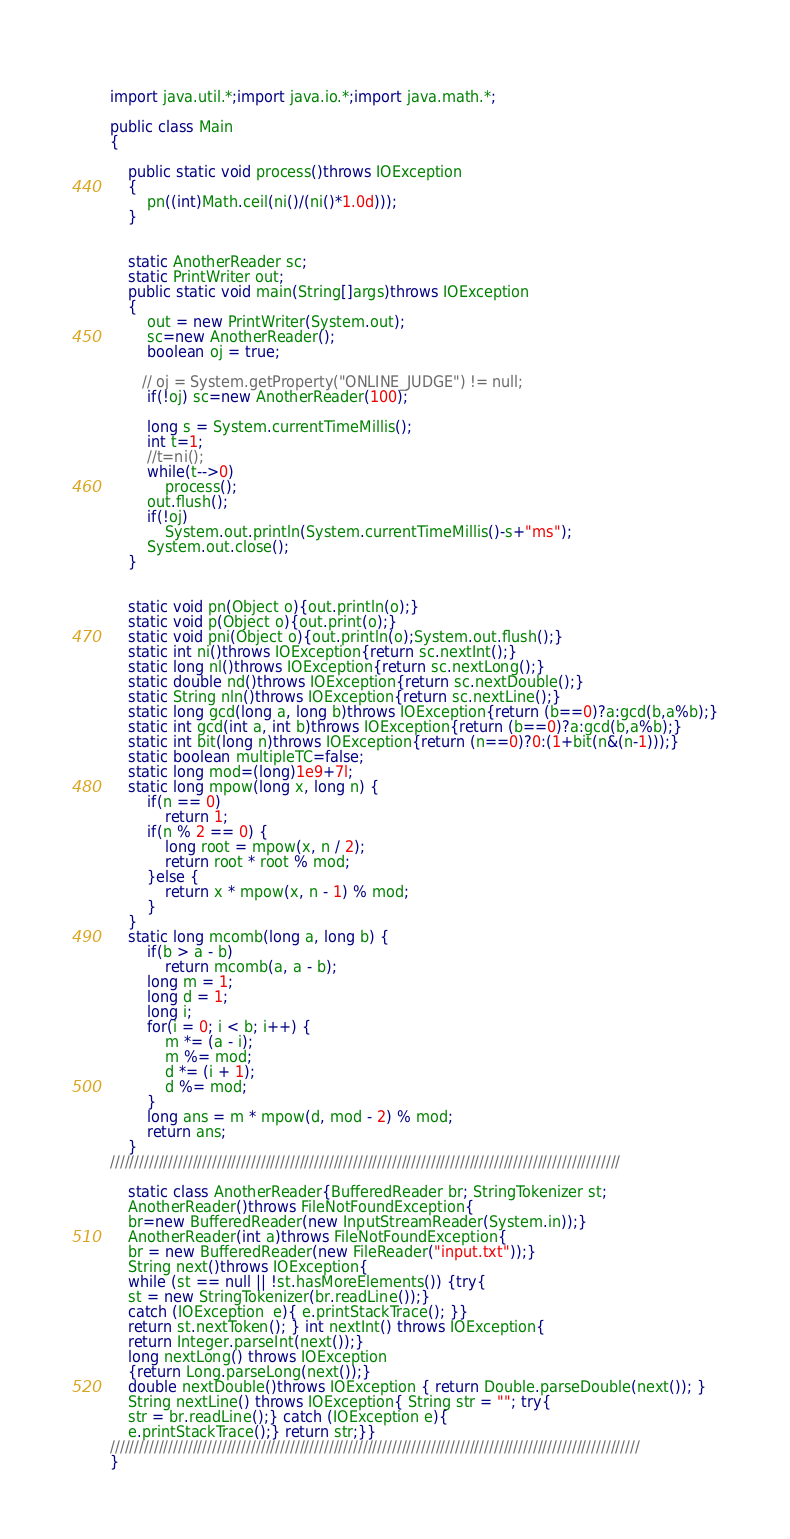Convert code to text. <code><loc_0><loc_0><loc_500><loc_500><_Java_>            
import java.util.*;import java.io.*;import java.math.*;

public class Main
{

    public static void process()throws IOException
    {
        pn((int)Math.ceil(ni()/(ni()*1.0d)));
    }


    static AnotherReader sc;
    static PrintWriter out;
    public static void main(String[]args)throws IOException
    {
        out = new PrintWriter(System.out);
        sc=new AnotherReader();
        boolean oj = true;

       // oj = System.getProperty("ONLINE_JUDGE") != null;
        if(!oj) sc=new AnotherReader(100);

        long s = System.currentTimeMillis();
        int t=1;
        //t=ni();
        while(t-->0)
            process();
        out.flush();
        if(!oj)
            System.out.println(System.currentTimeMillis()-s+"ms");
        System.out.close();  
    }
    
    
    static void pn(Object o){out.println(o);}
    static void p(Object o){out.print(o);}
    static void pni(Object o){out.println(o);System.out.flush();}
    static int ni()throws IOException{return sc.nextInt();}
    static long nl()throws IOException{return sc.nextLong();}
    static double nd()throws IOException{return sc.nextDouble();}
    static String nln()throws IOException{return sc.nextLine();}
    static long gcd(long a, long b)throws IOException{return (b==0)?a:gcd(b,a%b);}
    static int gcd(int a, int b)throws IOException{return (b==0)?a:gcd(b,a%b);}
    static int bit(long n)throws IOException{return (n==0)?0:(1+bit(n&(n-1)));}
    static boolean multipleTC=false;
    static long mod=(long)1e9+7l;
    static long mpow(long x, long n) {
        if(n == 0)
            return 1;
        if(n % 2 == 0) {
            long root = mpow(x, n / 2);
            return root * root % mod;
        }else {
            return x * mpow(x, n - 1) % mod;
        }
    }
    static long mcomb(long a, long b) {
        if(b > a - b)
            return mcomb(a, a - b);
        long m = 1;
        long d = 1;
        long i;
        for(i = 0; i < b; i++) {
            m *= (a - i);
            m %= mod;
            d *= (i + 1);
            d %= mod;
        }
        long ans = m * mpow(d, mod - 2) % mod;
        return ans;
    }
/////////////////////////////////////////////////////////////////////////////////////////////////////////

    static class AnotherReader{BufferedReader br; StringTokenizer st;
    AnotherReader()throws FileNotFoundException{
    br=new BufferedReader(new InputStreamReader(System.in));}
    AnotherReader(int a)throws FileNotFoundException{
    br = new BufferedReader(new FileReader("input.txt"));}
    String next()throws IOException{
    while (st == null || !st.hasMoreElements()) {try{
    st = new StringTokenizer(br.readLine());}
    catch (IOException  e){ e.printStackTrace(); }}
    return st.nextToken(); } int nextInt() throws IOException{
    return Integer.parseInt(next());}
    long nextLong() throws IOException
    {return Long.parseLong(next());}
    double nextDouble()throws IOException { return Double.parseDouble(next()); }
    String nextLine() throws IOException{ String str = ""; try{
    str = br.readLine();} catch (IOException e){
    e.printStackTrace();} return str;}}
/////////////////////////////////////////////////////////////////////////////////////////////////////////////
}</code> 